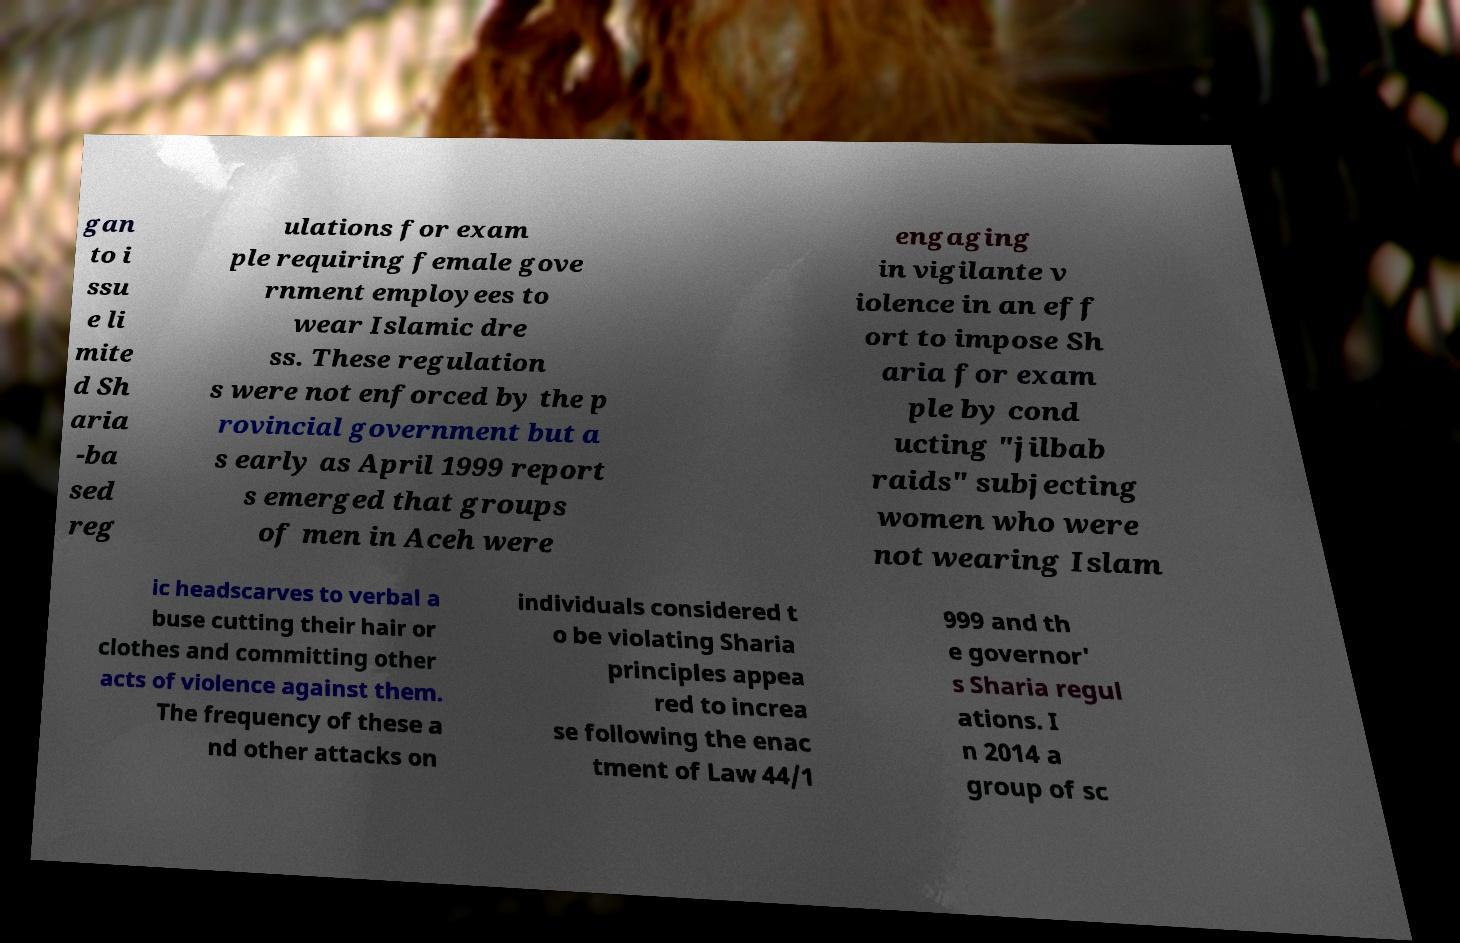For documentation purposes, I need the text within this image transcribed. Could you provide that? gan to i ssu e li mite d Sh aria -ba sed reg ulations for exam ple requiring female gove rnment employees to wear Islamic dre ss. These regulation s were not enforced by the p rovincial government but a s early as April 1999 report s emerged that groups of men in Aceh were engaging in vigilante v iolence in an eff ort to impose Sh aria for exam ple by cond ucting "jilbab raids" subjecting women who were not wearing Islam ic headscarves to verbal a buse cutting their hair or clothes and committing other acts of violence against them. The frequency of these a nd other attacks on individuals considered t o be violating Sharia principles appea red to increa se following the enac tment of Law 44/1 999 and th e governor' s Sharia regul ations. I n 2014 a group of sc 